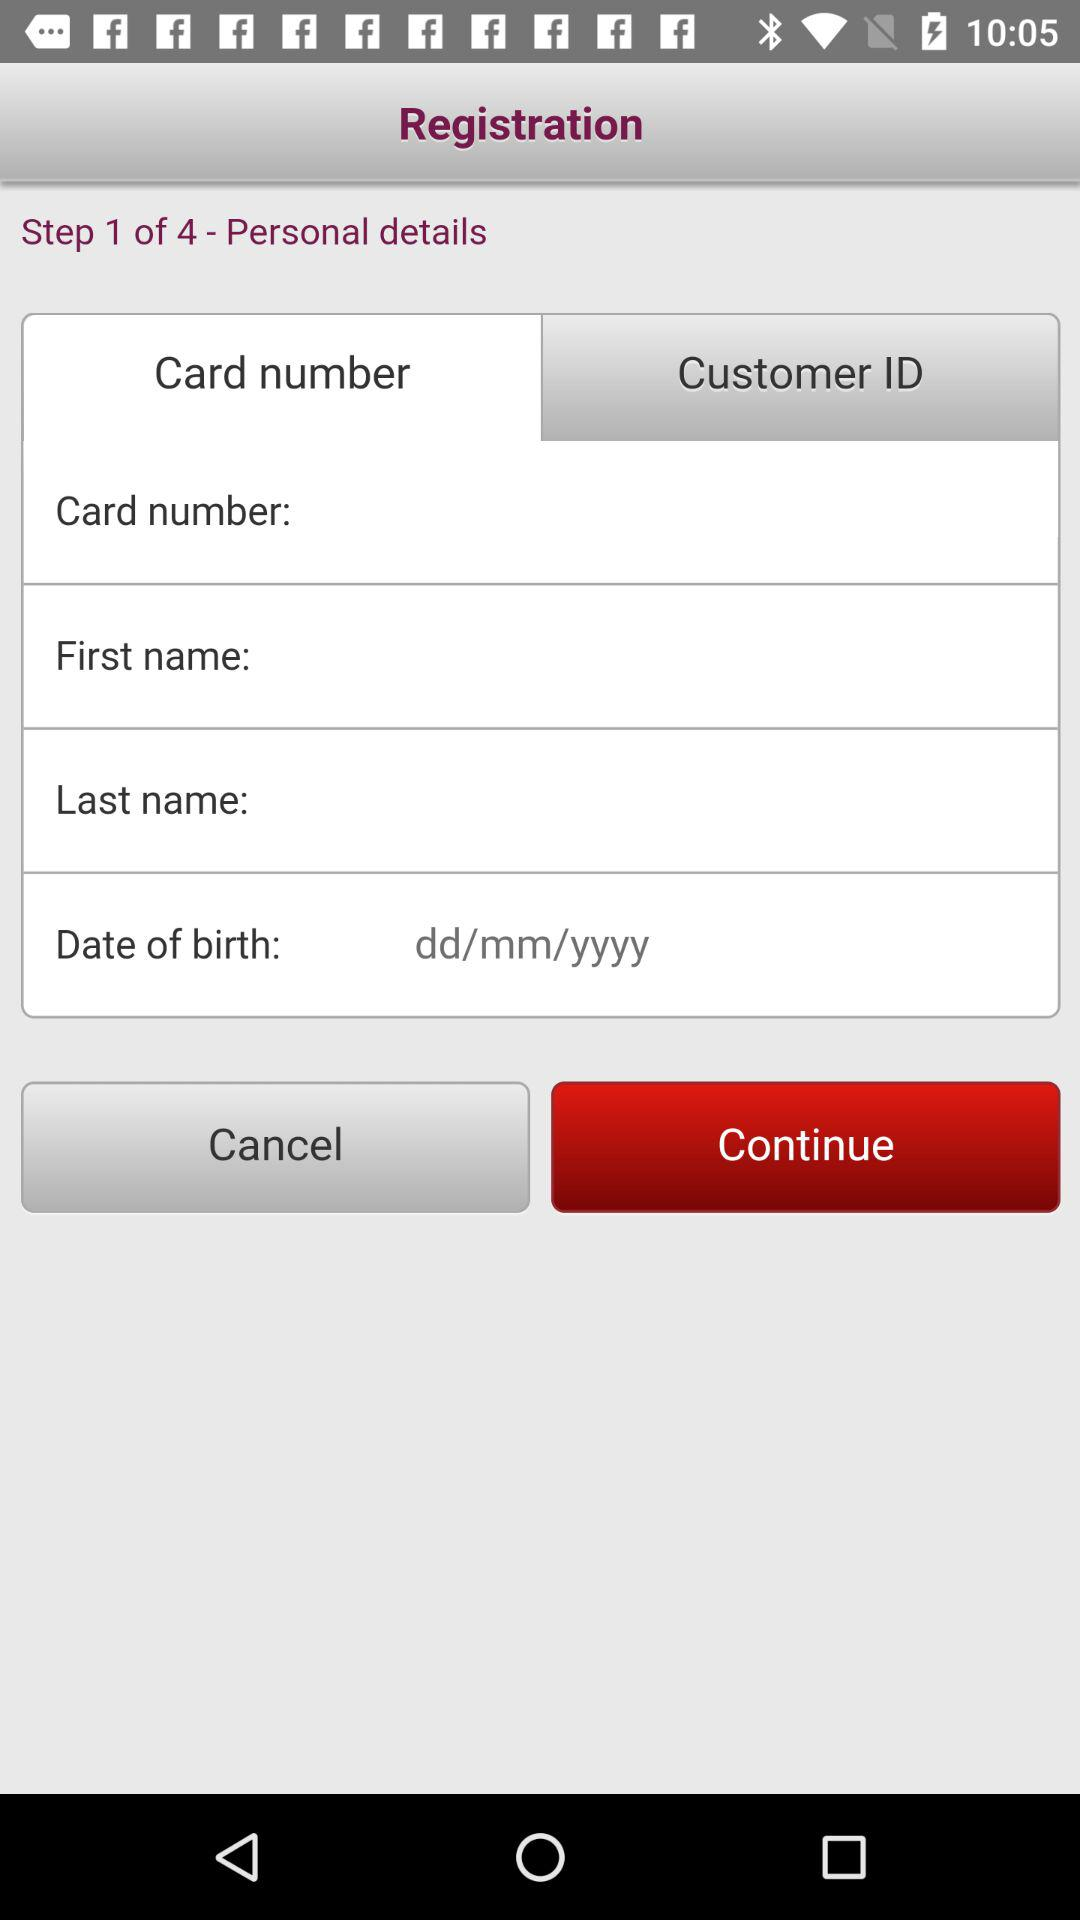Which tab is selected? The selected tab is "Card number". 